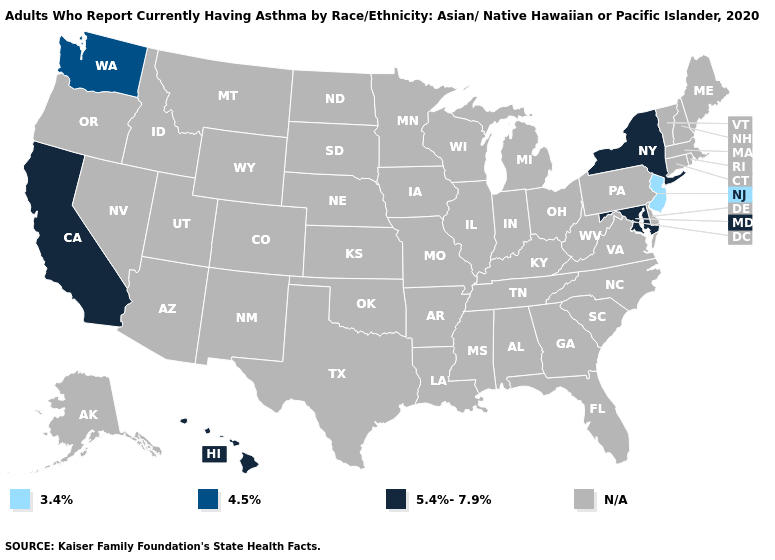Name the states that have a value in the range 4.5%?
Keep it brief. Washington. What is the value of Michigan?
Write a very short answer. N/A. Name the states that have a value in the range 4.5%?
Write a very short answer. Washington. Name the states that have a value in the range 3.4%?
Answer briefly. New Jersey. Does the first symbol in the legend represent the smallest category?
Quick response, please. Yes. Does New York have the highest value in the USA?
Concise answer only. Yes. Which states have the highest value in the USA?
Concise answer only. California, Hawaii, Maryland, New York. Which states hav the highest value in the South?
Concise answer only. Maryland. Which states have the lowest value in the USA?
Write a very short answer. New Jersey. What is the value of Rhode Island?
Be succinct. N/A. What is the value of Hawaii?
Quick response, please. 5.4%-7.9%. 